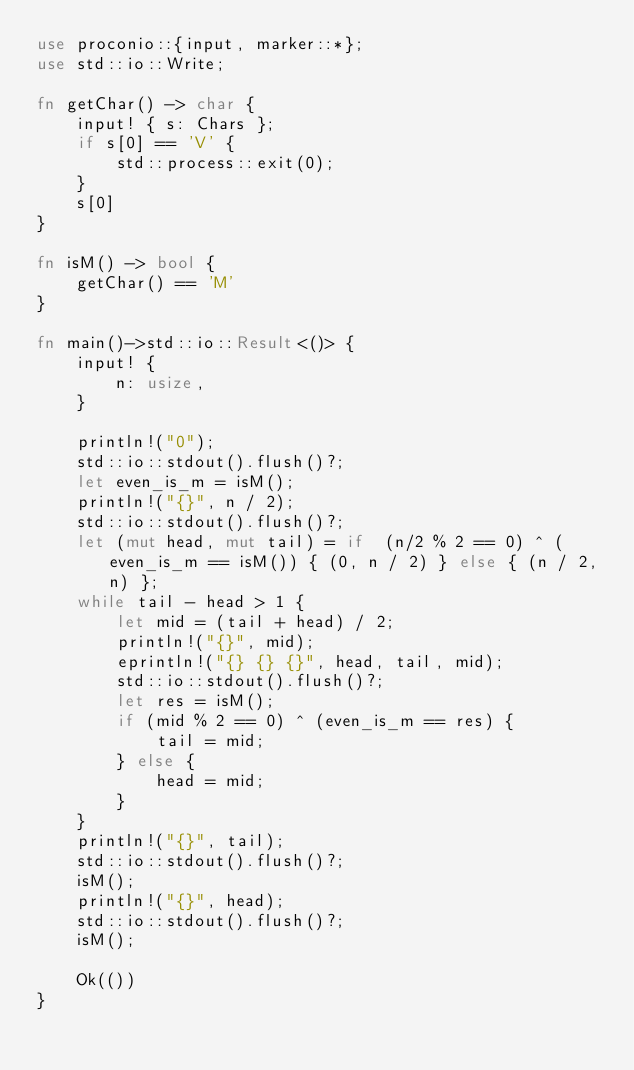<code> <loc_0><loc_0><loc_500><loc_500><_Rust_>use proconio::{input, marker::*};
use std::io::Write;

fn getChar() -> char {
    input! { s: Chars };
    if s[0] == 'V' {
        std::process::exit(0);
    }
    s[0]
}

fn isM() -> bool {
    getChar() == 'M'
}

fn main()->std::io::Result<()> {
    input! {
        n: usize,
    }

    println!("0");
    std::io::stdout().flush()?;
    let even_is_m = isM();
    println!("{}", n / 2);
    std::io::stdout().flush()?;
    let (mut head, mut tail) = if  (n/2 % 2 == 0) ^ (even_is_m == isM()) { (0, n / 2) } else { (n / 2, n) };
    while tail - head > 1 {
        let mid = (tail + head) / 2;
        println!("{}", mid);
        eprintln!("{} {} {}", head, tail, mid);
        std::io::stdout().flush()?;
        let res = isM();
        if (mid % 2 == 0) ^ (even_is_m == res) {
            tail = mid;
        } else {
            head = mid;
        }
    }
    println!("{}", tail);
    std::io::stdout().flush()?;
    isM();
    println!("{}", head);
    std::io::stdout().flush()?;
    isM();

    Ok(())
}
</code> 